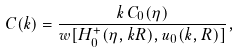<formula> <loc_0><loc_0><loc_500><loc_500>C ( k ) = \frac { k \, C _ { 0 } ( \eta ) } { w [ H ^ { + } _ { 0 } ( \eta , k R ) , u _ { 0 } ( k , R ) ] } ,</formula> 